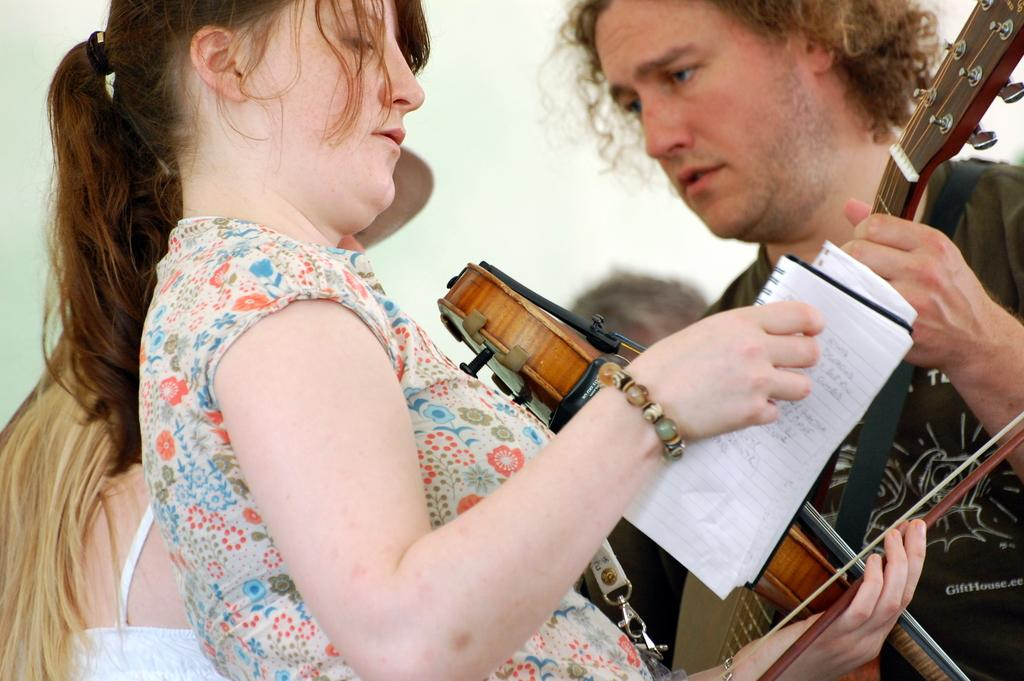What is the woman in the center of the image doing? The woman is standing in the center of the image and holding a paper. What is the man on the right side of the image holding? The man is holding a violin. What can be seen in the background of the image? There is a wall in the background of the image. What type of cart is being used to transport the wool in the image? There is no cart or wool present in the image. 